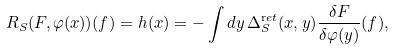Convert formula to latex. <formula><loc_0><loc_0><loc_500><loc_500>R _ { S } ( F , \varphi ( x ) ) ( f ) = h ( x ) = - \int d y \, \Delta _ { S } ^ { \mathrm r e t } ( x , y ) \frac { \delta F } { \delta \varphi ( y ) } ( f ) ,</formula> 